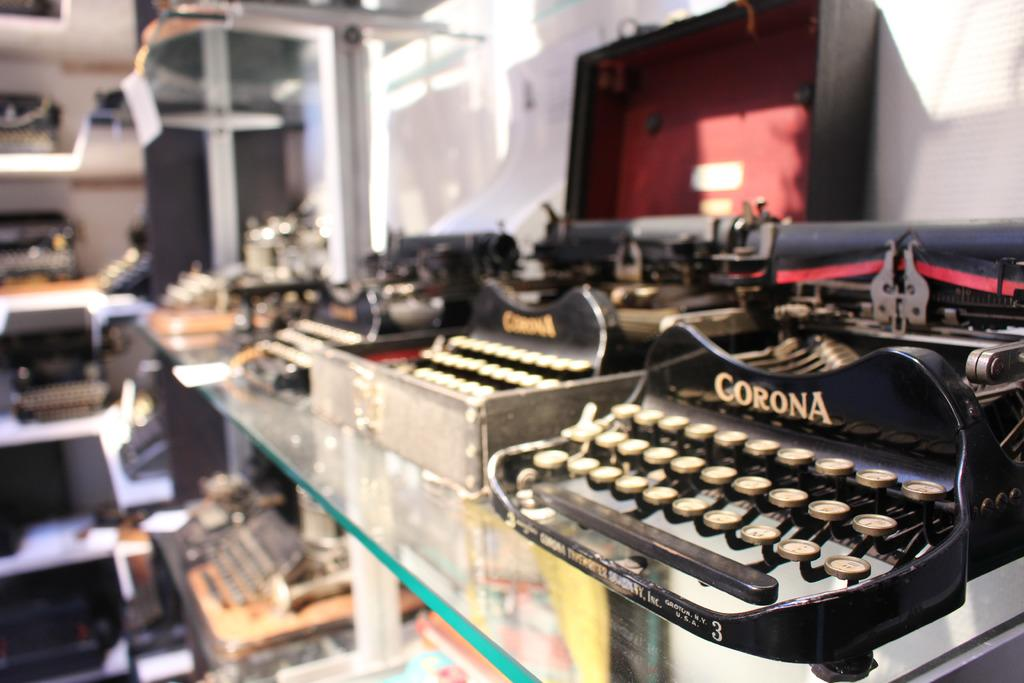What objects are visible in the image? There are typing machines in the image. Where are the typing machines located? The typing machines are on shelves. What type of establishment might the shelves be located in? The shelves are in a store. What type of skin can be seen on the straw in the image? There is no straw or skin present in the image; it features typing machines on shelves in a store. 